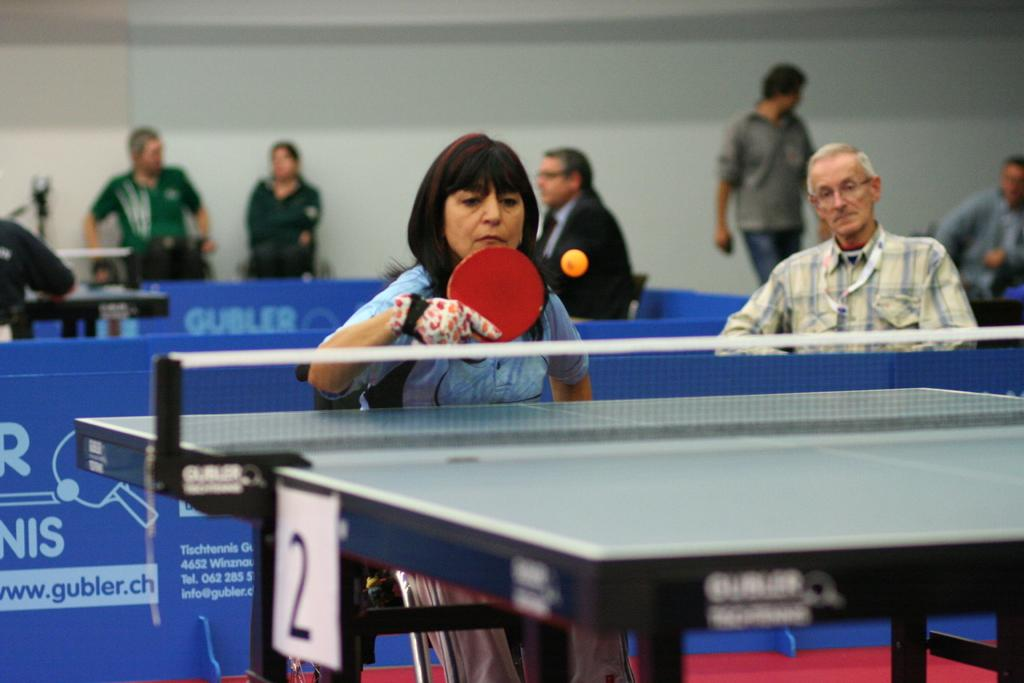Who is the main subject in the image? There is a woman in the image. What is the woman doing in the image? The woman is playing table tennis. Can you describe the setting of the image? There are other persons in the background of the image. What type of shoe is the woman wearing while playing table tennis in the image? There is no information about the woman's shoes in the image, so we cannot determine what type of shoe she is wearing. 